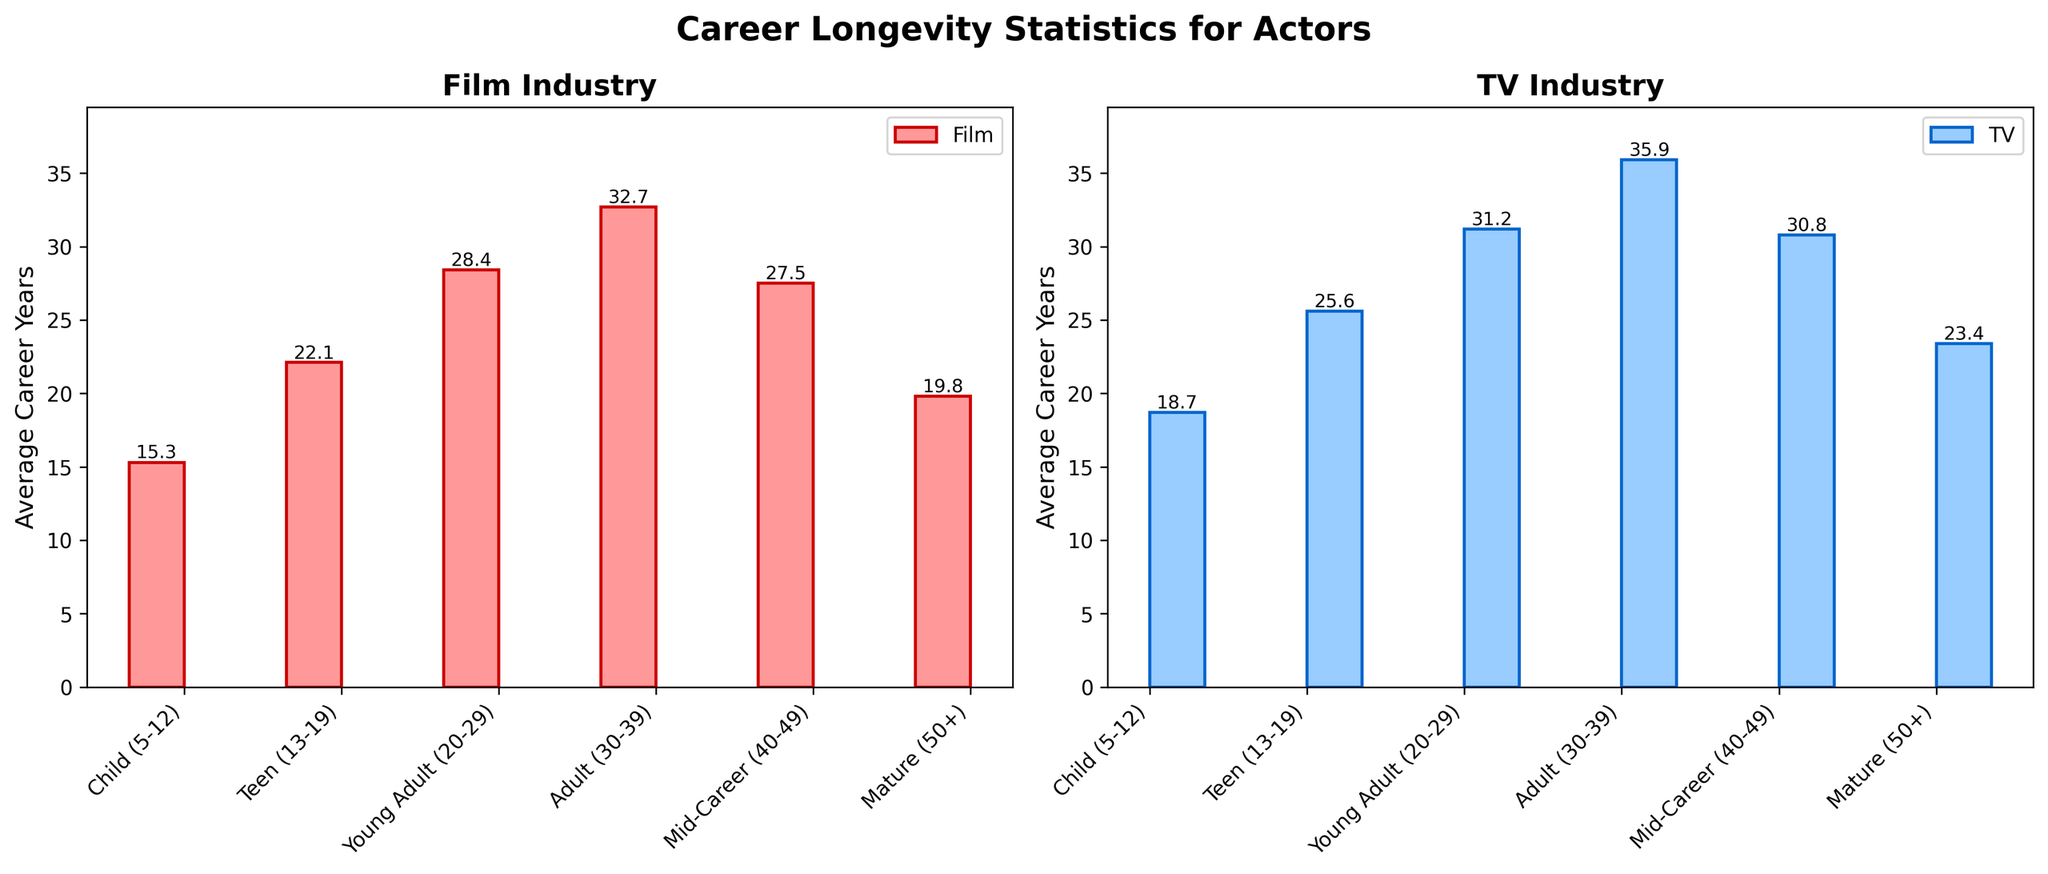What's the title of the figure? The figure's title is written at the top and reads, "Career Longevity Statistics for Actors"
Answer: Career Longevity Statistics for Actors How many age groups are there in the data? By counting the unique age groups on the x-axis of the subplots, we can see there are six distinct age groups.
Answer: 6 Which age group has the highest average career years in the Film industry? The bar representing Adult (30-39) in the Film industry subplot is the tallest, indicating the highest average career years.
Answer: Adult (30-39) How does the average career longevity of TV actors in the Teen age group compare to that of Film actors in the same group? In the TV subplot, the Teen (13-19) age group bar is taller, showing a higher average career years compared to the Film subplot.
Answer: TV actors have longer careers What's the average difference in career longevity between TV and Film actors for the Young Adult age group? Subtract the Young Adult average career years in Film (28.4) from the TV industry (31.2): 31.2 - 28.4 = 2.8
Answer: 2.8 years Which industry shows a larger decrease in average career years when comparing Mature (50+) to Adult (30-39) age groups? By comparing the height of the bars, the Film industry shows a decrease from 32.7 to 19.8, while the TV industry decreases from 35.9 to 23.4. The Film industry decreases by 12.9 years and the TV industry by 12.5 years.
Answer: Film industry Is there an age group where Film actors have a longer average career than TV actors? If so, which one? By comparing the heights of the bars between the two subplots, the Young Adult (20-29) age group is the only one where the Film actors have an average career (28.4 years) shorter than TV actors (31.2 years).
Answer: No What is the combined average career longevity of Film and TV actors in the Mid-Career age group? Add the average career years for Film (27.5) and TV (30.8), and then divide by 2: (27.5 + 30.8) / 2 = 29.15
Answer: 29.15 years What is the range of average career years for Film actors? The range is found by subtracting the minimum value (Child 15.3) from the maximum value (Adult 32.7) in the Film subplot: 32.7 - 15.3 = 17.4
Answer: 17.4 years 